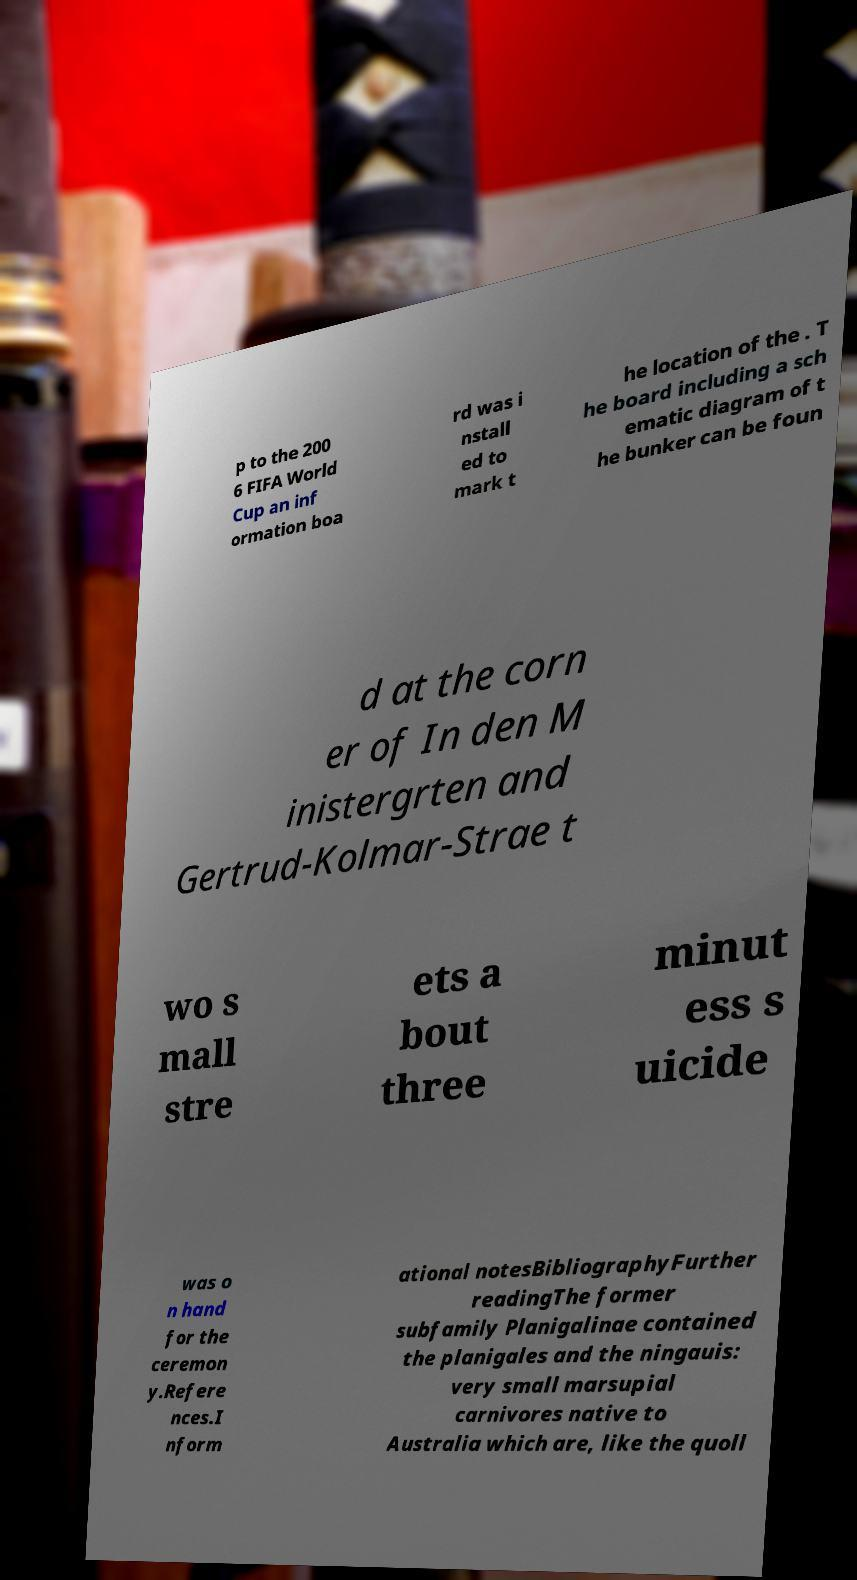There's text embedded in this image that I need extracted. Can you transcribe it verbatim? p to the 200 6 FIFA World Cup an inf ormation boa rd was i nstall ed to mark t he location of the . T he board including a sch ematic diagram of t he bunker can be foun d at the corn er of In den M inistergrten and Gertrud-Kolmar-Strae t wo s mall stre ets a bout three minut ess s uicide was o n hand for the ceremon y.Refere nces.I nform ational notesBibliographyFurther readingThe former subfamily Planigalinae contained the planigales and the ningauis: very small marsupial carnivores native to Australia which are, like the quoll 